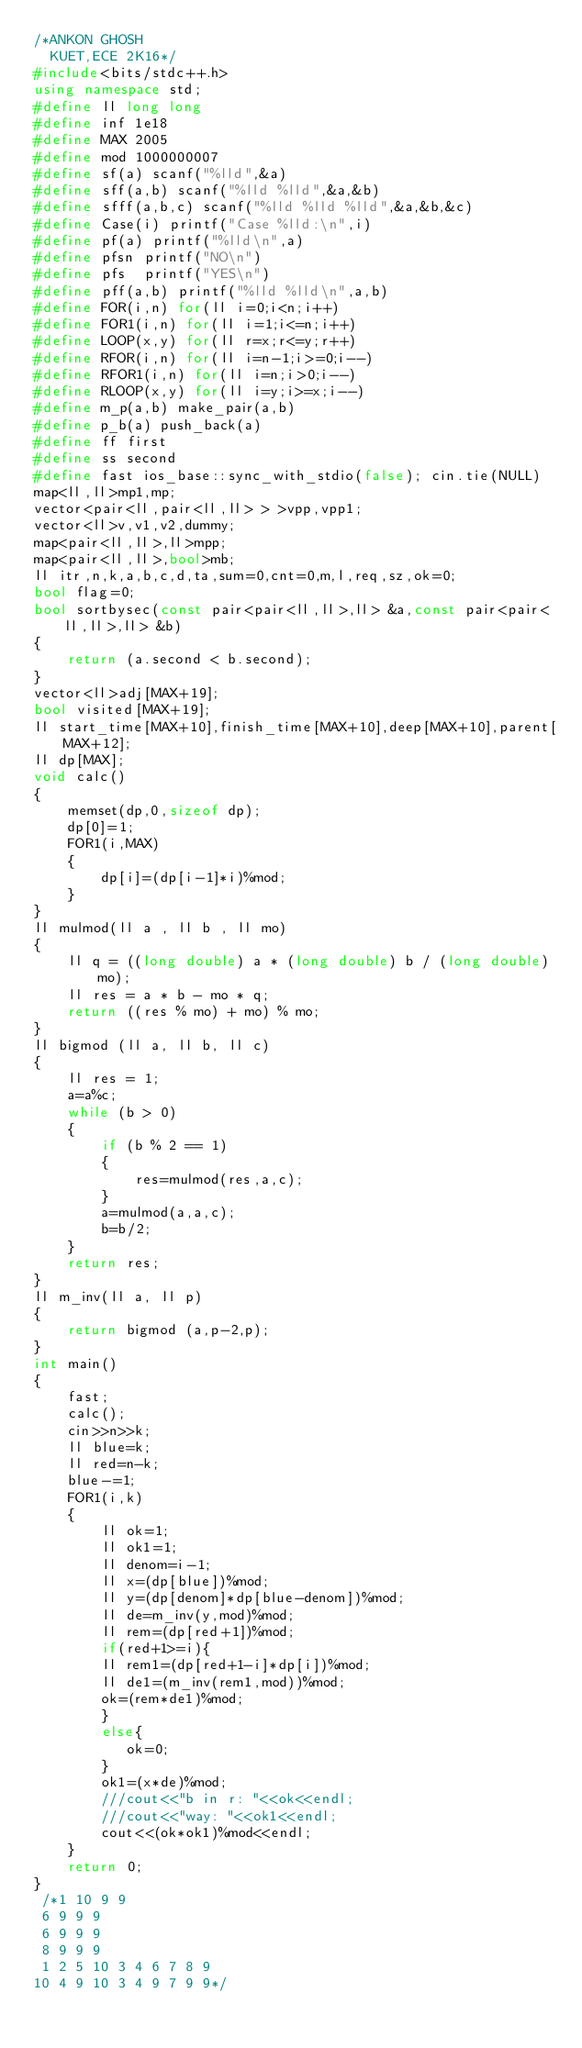Convert code to text. <code><loc_0><loc_0><loc_500><loc_500><_C++_>/*ANKON GHOSH
  KUET,ECE 2K16*/
#include<bits/stdc++.h>
using namespace std;
#define ll long long
#define inf 1e18
#define MAX 2005
#define mod 1000000007
#define sf(a) scanf("%lld",&a)
#define sff(a,b) scanf("%lld %lld",&a,&b)
#define sfff(a,b,c) scanf("%lld %lld %lld",&a,&b,&c)
#define Case(i) printf("Case %lld:\n",i)
#define pf(a) printf("%lld\n",a)
#define pfsn printf("NO\n")
#define pfs  printf("YES\n")
#define pff(a,b) printf("%lld %lld\n",a,b)
#define FOR(i,n) for(ll i=0;i<n;i++)
#define FOR1(i,n) for(ll i=1;i<=n;i++)
#define LOOP(x,y) for(ll r=x;r<=y;r++)
#define RFOR(i,n) for(ll i=n-1;i>=0;i--)
#define RFOR1(i,n) for(ll i=n;i>0;i--)
#define RLOOP(x,y) for(ll i=y;i>=x;i--)
#define m_p(a,b) make_pair(a,b)
#define p_b(a) push_back(a)
#define ff first
#define ss second
#define fast ios_base::sync_with_stdio(false); cin.tie(NULL)
map<ll,ll>mp1,mp;
vector<pair<ll,pair<ll,ll> > >vpp,vpp1;
vector<ll>v,v1,v2,dummy;
map<pair<ll,ll>,ll>mpp;
map<pair<ll,ll>,bool>mb;
ll itr,n,k,a,b,c,d,ta,sum=0,cnt=0,m,l,req,sz,ok=0;
bool flag=0;
bool sortbysec(const pair<pair<ll,ll>,ll> &a,const pair<pair<ll,ll>,ll> &b)
{
    return (a.second < b.second);
}
vector<ll>adj[MAX+19];
bool visited[MAX+19];
ll start_time[MAX+10],finish_time[MAX+10],deep[MAX+10],parent[MAX+12];
ll dp[MAX];
void calc()
{
    memset(dp,0,sizeof dp);
    dp[0]=1;
    FOR1(i,MAX)
    {
        dp[i]=(dp[i-1]*i)%mod;
    }
}
ll mulmod(ll a , ll b , ll mo)
{
    ll q = ((long double) a * (long double) b / (long double) mo);
    ll res = a * b - mo * q;
    return ((res % mo) + mo) % mo;
}
ll bigmod (ll a, ll b, ll c)
{
    ll res = 1;
    a=a%c;
    while (b > 0)
    {
        if (b % 2 == 1)
        {
            res=mulmod(res,a,c);
        }
        a=mulmod(a,a,c);
        b=b/2;
    }
    return res;
}
ll m_inv(ll a, ll p)
{
    return bigmod (a,p-2,p);
}
int main()
{
    fast;
    calc();
    cin>>n>>k;
    ll blue=k;
    ll red=n-k;
    blue-=1;
    FOR1(i,k)
    {
        ll ok=1;
        ll ok1=1;
        ll denom=i-1;
        ll x=(dp[blue])%mod;
        ll y=(dp[denom]*dp[blue-denom])%mod;
        ll de=m_inv(y,mod)%mod;
        ll rem=(dp[red+1])%mod;
        if(red+1>=i){
        ll rem1=(dp[red+1-i]*dp[i])%mod;
        ll de1=(m_inv(rem1,mod))%mod;
        ok=(rem*de1)%mod;
        }
        else{
           ok=0;
        }
        ok1=(x*de)%mod;
        ///cout<<"b in r: "<<ok<<endl;
        ///cout<<"way: "<<ok1<<endl;
        cout<<(ok*ok1)%mod<<endl;
    }
    return 0;
}
 /*1 10 9 9
 6 9 9 9
 6 9 9 9
 8 9 9 9
 1 2 5 10 3 4 6 7 8 9
10 4 9 10 3 4 9 7 9 9*/
</code> 